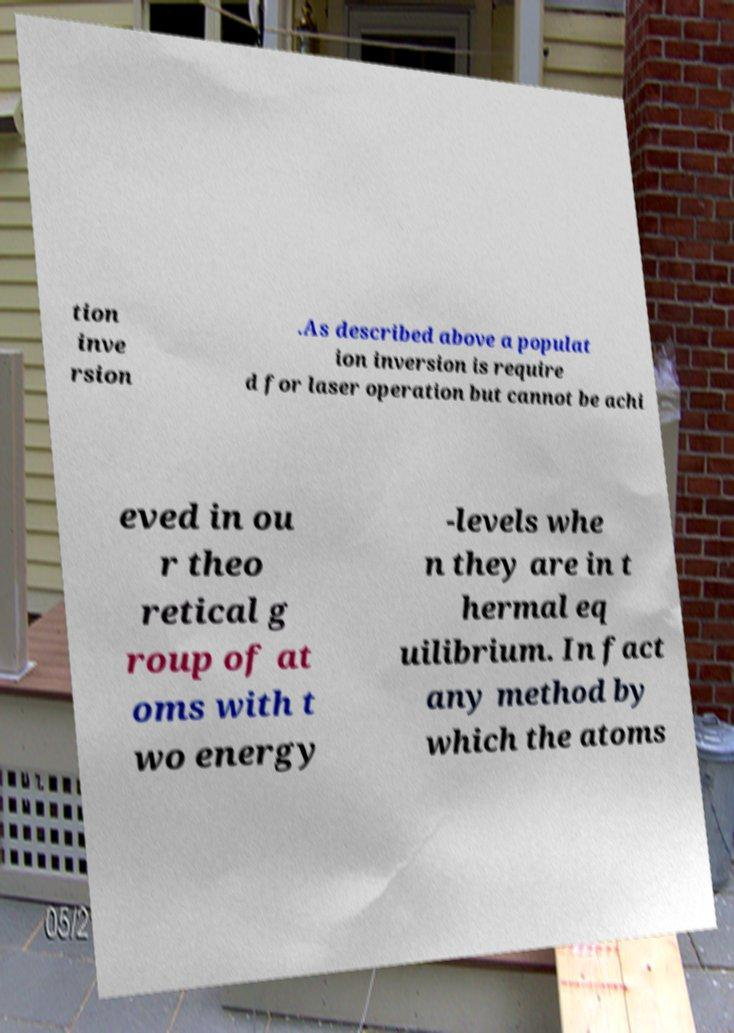Can you accurately transcribe the text from the provided image for me? tion inve rsion .As described above a populat ion inversion is require d for laser operation but cannot be achi eved in ou r theo retical g roup of at oms with t wo energy -levels whe n they are in t hermal eq uilibrium. In fact any method by which the atoms 